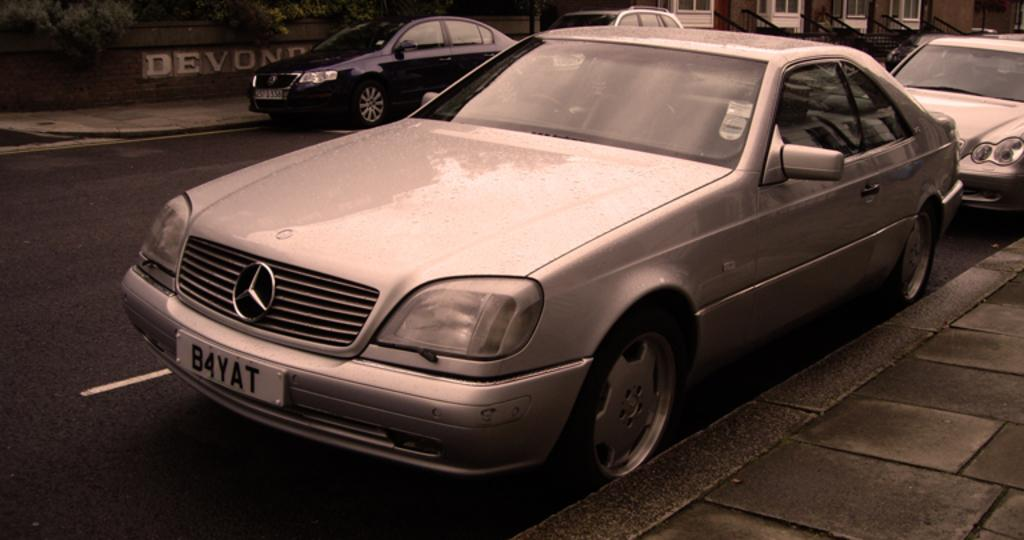<image>
Describe the image concisely. a license plate that has B4YAT on it 